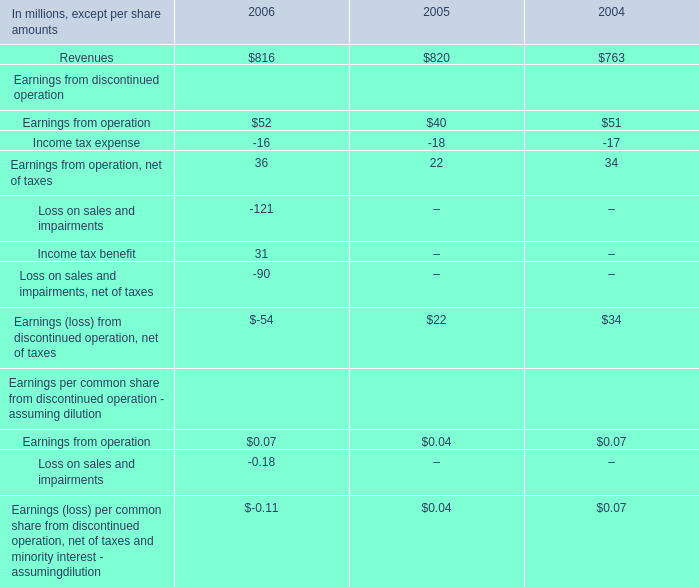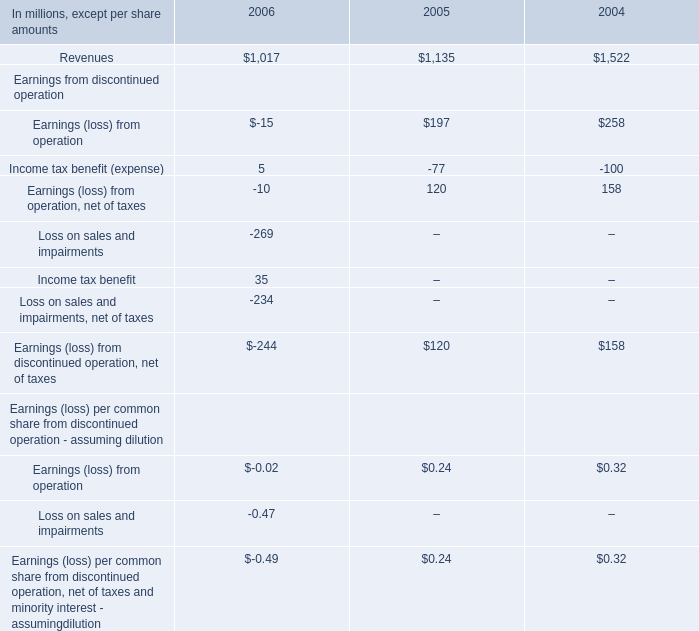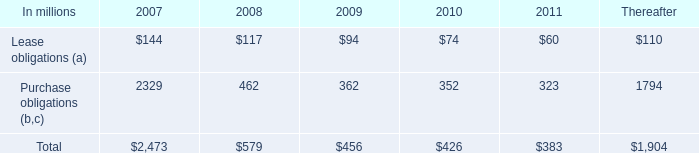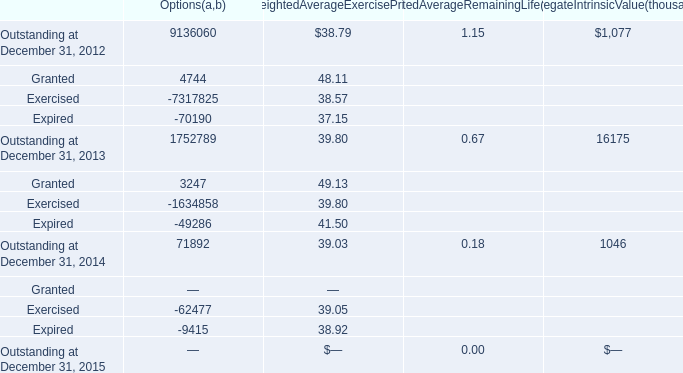As As the chart 3 shows,what was the total amount of Weighted Average Exercise Price for Outstanding in the range of 20 and 51 ? 
Computations: ((38.79 + 39.80) + 39.03)
Answer: 117.62. 